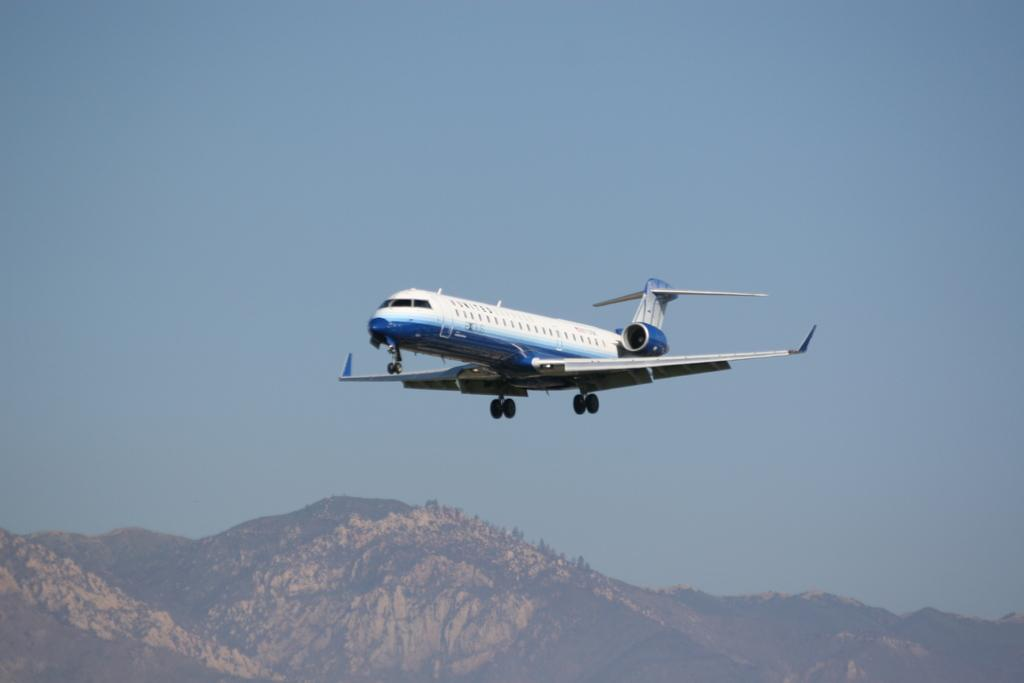What is the main subject of the image? The main subject of the image is an aircraft. What colors can be seen on the aircraft? The aircraft is white and blue in color. What is the aircraft doing in the image? The aircraft is flying in the air. What can be seen in the background of the image? There are mountains and the sky visible in the background of the image. What type of books can be found in the library depicted in the image? There is no library present in the image; it features an aircraft flying in the air. How many passengers are visible in the image? The image does not show any passengers; it only shows an aircraft flying in the air. 